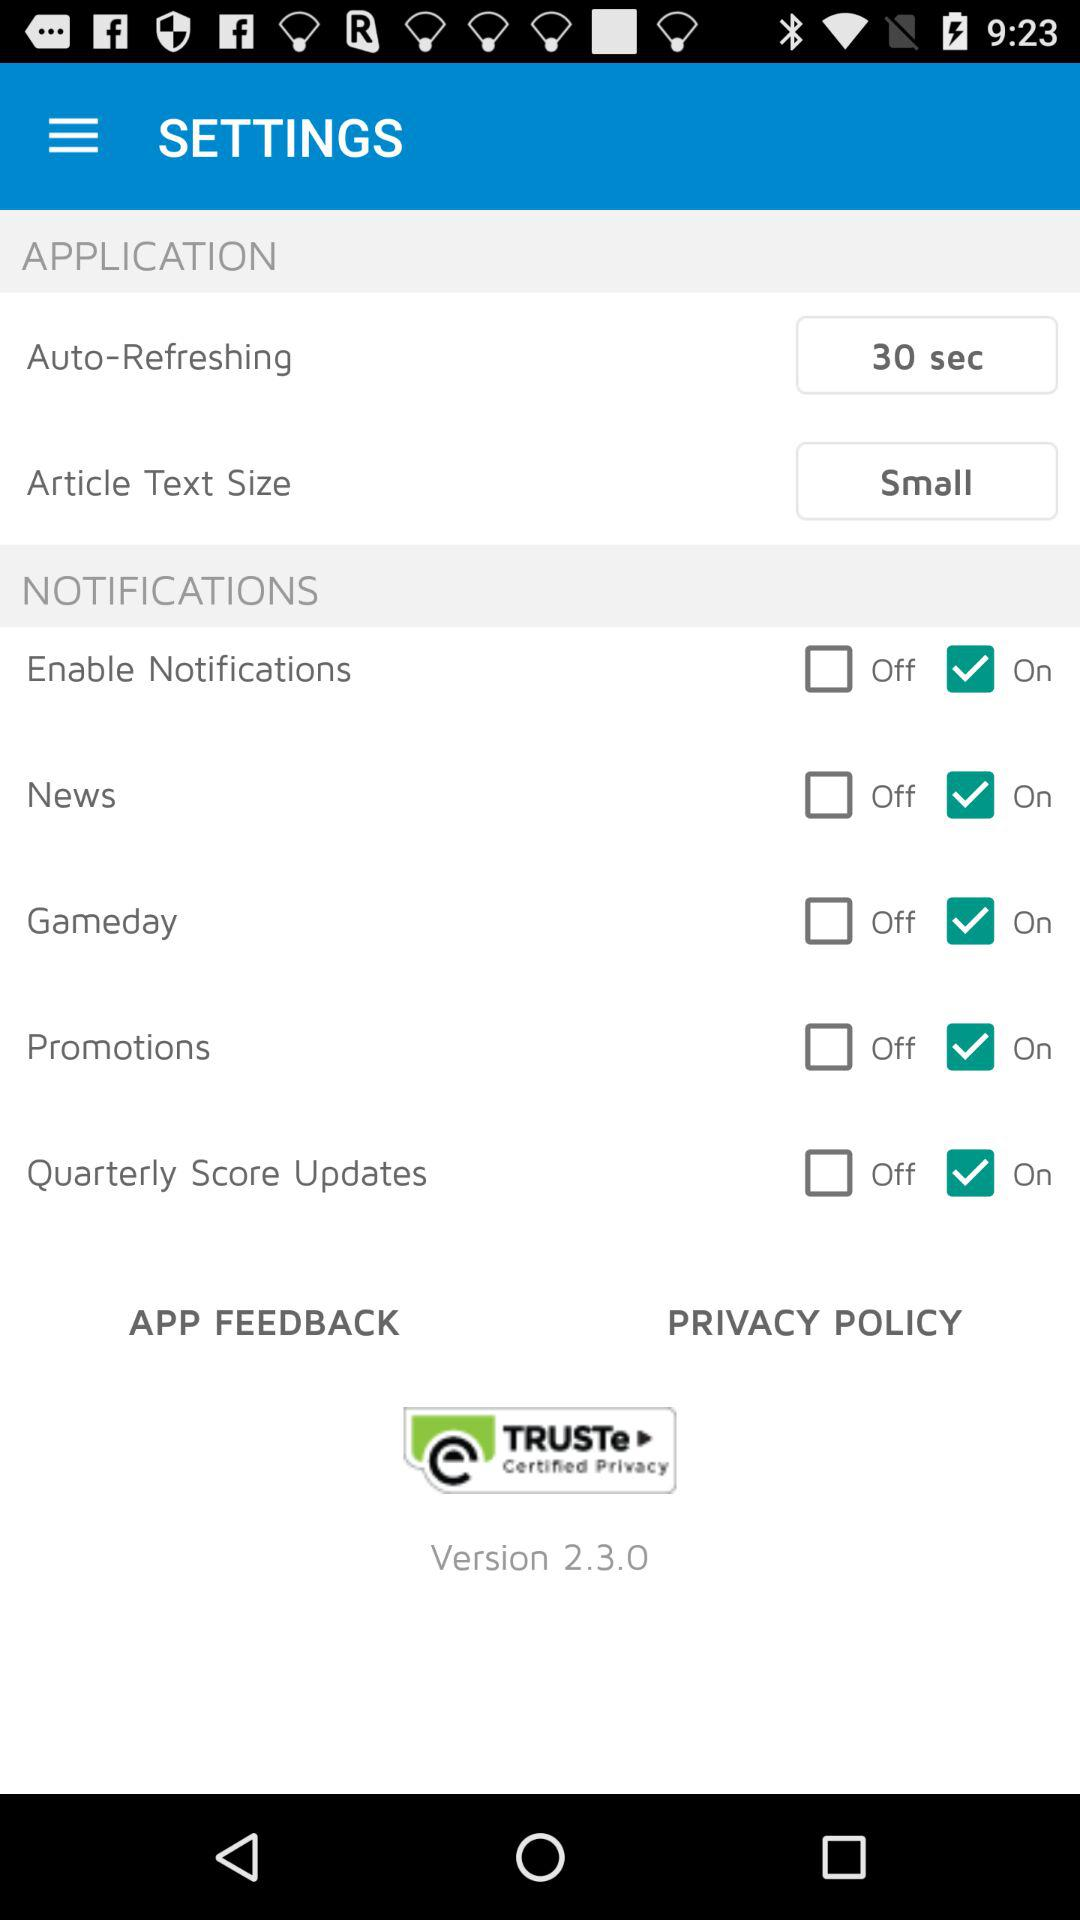What is the version number? The version number is 2.3.0. 